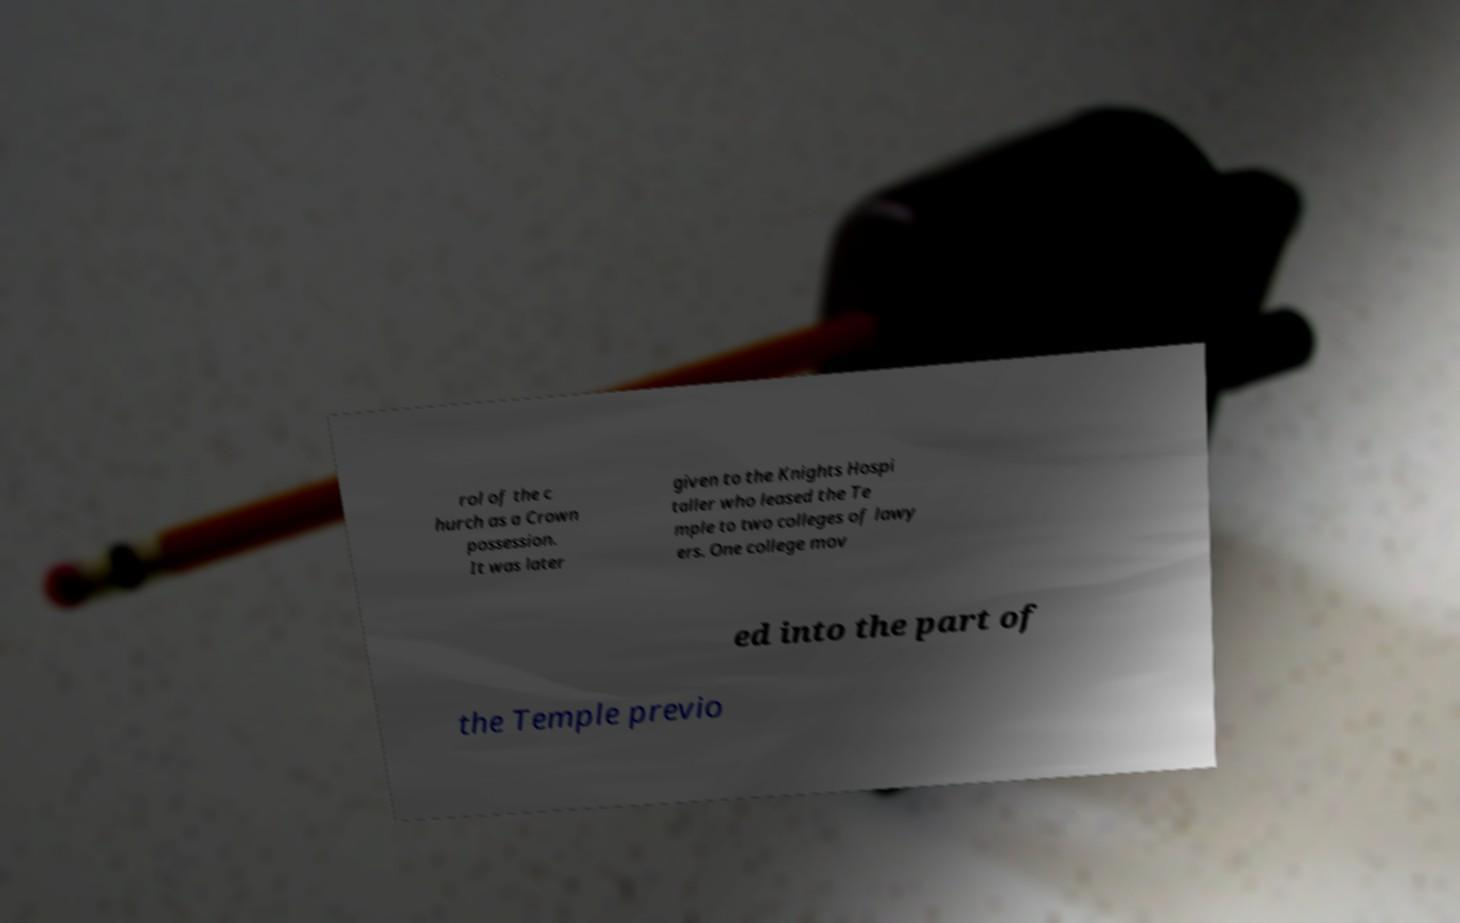For documentation purposes, I need the text within this image transcribed. Could you provide that? rol of the c hurch as a Crown possession. It was later given to the Knights Hospi taller who leased the Te mple to two colleges of lawy ers. One college mov ed into the part of the Temple previo 